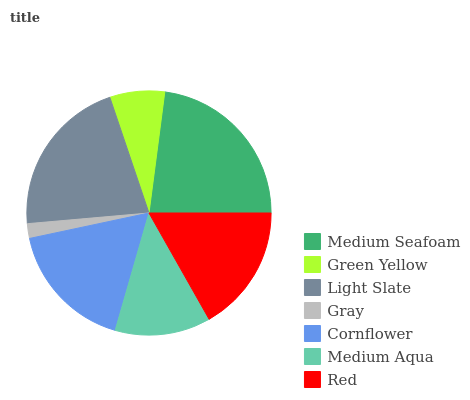Is Gray the minimum?
Answer yes or no. Yes. Is Medium Seafoam the maximum?
Answer yes or no. Yes. Is Green Yellow the minimum?
Answer yes or no. No. Is Green Yellow the maximum?
Answer yes or no. No. Is Medium Seafoam greater than Green Yellow?
Answer yes or no. Yes. Is Green Yellow less than Medium Seafoam?
Answer yes or no. Yes. Is Green Yellow greater than Medium Seafoam?
Answer yes or no. No. Is Medium Seafoam less than Green Yellow?
Answer yes or no. No. Is Red the high median?
Answer yes or no. Yes. Is Red the low median?
Answer yes or no. Yes. Is Medium Aqua the high median?
Answer yes or no. No. Is Medium Seafoam the low median?
Answer yes or no. No. 